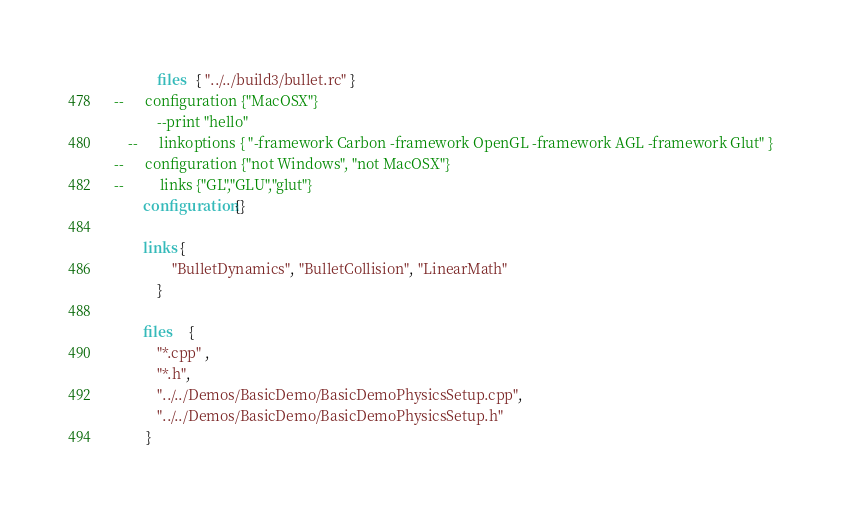Convert code to text. <code><loc_0><loc_0><loc_500><loc_500><_Lua_>	 		files   { "../../build3/bullet.rc" }
--		configuration {"MacOSX"}
			--print "hello"
	-- 		linkoptions { "-framework Carbon -framework OpenGL -framework AGL -framework Glut" } 	
--		configuration {"not Windows", "not MacOSX"}
--			links {"GL","GLU","glut"}
		configuration{}
	
		links { 
				"BulletDynamics", "BulletCollision", "LinearMath"
			}
		
		files     { 
		 	"*.cpp" ,
		 	"*.h",
		 	"../../Demos/BasicDemo/BasicDemoPhysicsSetup.cpp",
			"../../Demos/BasicDemo/BasicDemoPhysicsSetup.h"
		 }
</code> 